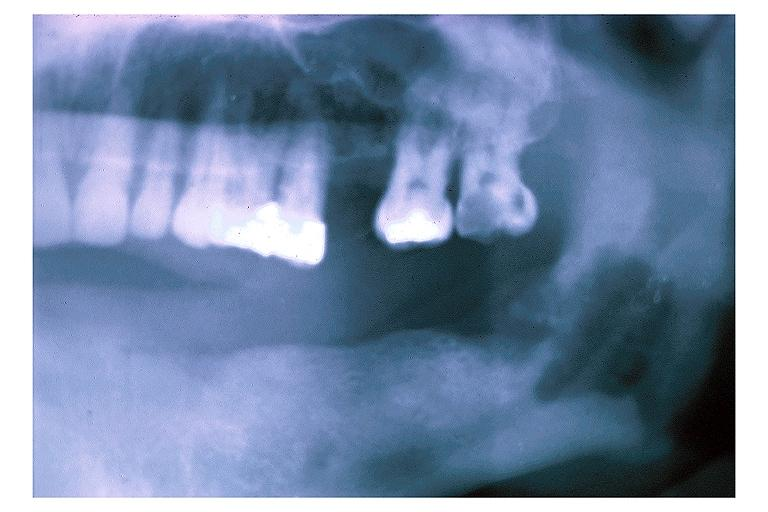what does this image show?
Answer the question using a single word or phrase. Chronic osteomyelitis 